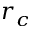Convert formula to latex. <formula><loc_0><loc_0><loc_500><loc_500>r _ { c }</formula> 